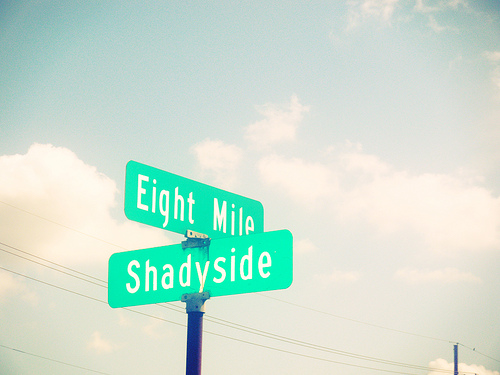Can you speculate on the type of area where this photo was taken? The photo shows a clear sky which could imply a day with good weather. The presence of street signs suggests an urban or suburban area. Without more context, it's difficult to be certain, but it could be a residential neighborhood or the outskirts of a city. 